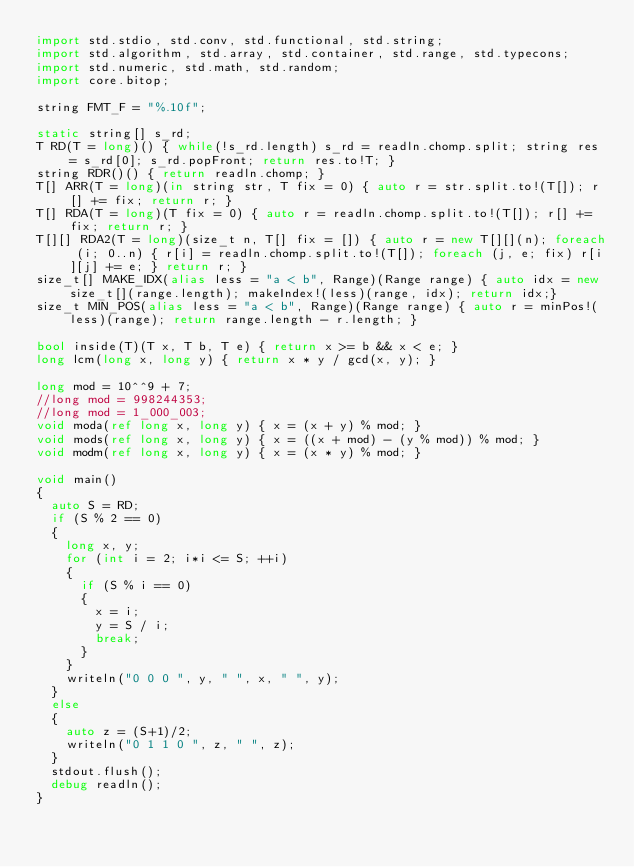<code> <loc_0><loc_0><loc_500><loc_500><_D_>import std.stdio, std.conv, std.functional, std.string;
import std.algorithm, std.array, std.container, std.range, std.typecons;
import std.numeric, std.math, std.random;
import core.bitop;

string FMT_F = "%.10f";

static string[] s_rd;
T RD(T = long)() { while(!s_rd.length) s_rd = readln.chomp.split; string res = s_rd[0]; s_rd.popFront; return res.to!T; }
string RDR()() { return readln.chomp; }
T[] ARR(T = long)(in string str, T fix = 0) { auto r = str.split.to!(T[]); r[] += fix; return r; }
T[] RDA(T = long)(T fix = 0) { auto r = readln.chomp.split.to!(T[]); r[] += fix; return r; }
T[][] RDA2(T = long)(size_t n, T[] fix = []) { auto r = new T[][](n); foreach (i; 0..n) { r[i] = readln.chomp.split.to!(T[]); foreach (j, e; fix) r[i][j] += e; } return r; }
size_t[] MAKE_IDX(alias less = "a < b", Range)(Range range) { auto idx = new size_t[](range.length); makeIndex!(less)(range, idx); return idx;}
size_t MIN_POS(alias less = "a < b", Range)(Range range) { auto r = minPos!(less)(range); return range.length - r.length; }

bool inside(T)(T x, T b, T e) { return x >= b && x < e; }
long lcm(long x, long y) { return x * y / gcd(x, y); }

long mod = 10^^9 + 7;
//long mod = 998244353;
//long mod = 1_000_003;
void moda(ref long x, long y) { x = (x + y) % mod; }
void mods(ref long x, long y) { x = ((x + mod) - (y % mod)) % mod; }
void modm(ref long x, long y) { x = (x * y) % mod; }

void main()
{
	auto S = RD;
	if (S % 2 == 0)
	{
		long x, y;
		for (int i = 2; i*i <= S; ++i)
		{
			if (S % i == 0)
			{
				x = i;
				y = S / i;
				break;
			}
		}
		writeln("0 0 0 ", y, " ", x, " ", y);
	}
	else
	{
		auto z = (S+1)/2;
		writeln("0 1 1 0 ", z, " ", z);
	}
	stdout.flush();
	debug readln();
}
</code> 